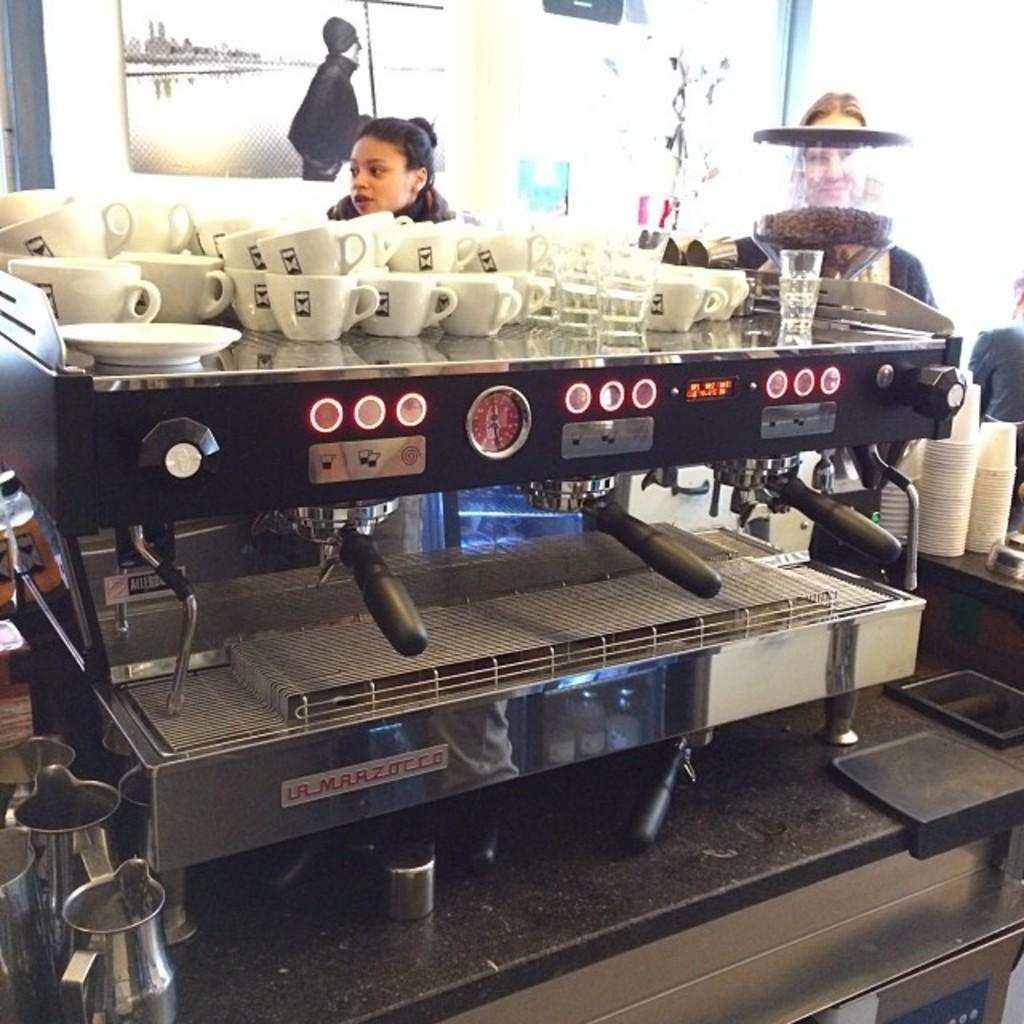<image>
Summarize the visual content of the image. Professional coffee machine made by La Marzocco with bunch of cups on top 